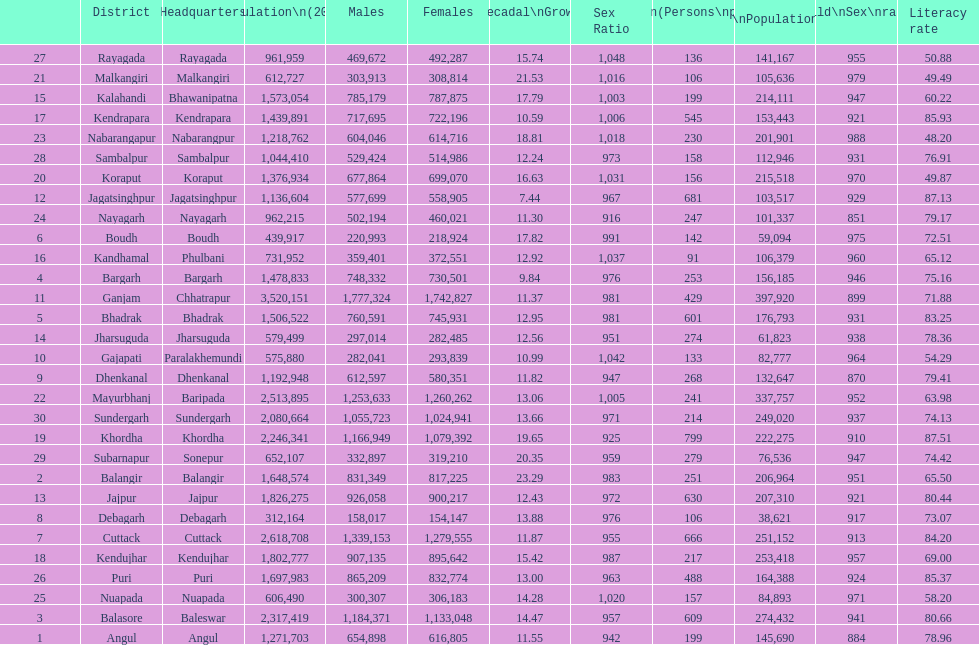Which district has a higher population, angul or cuttack? Cuttack. 